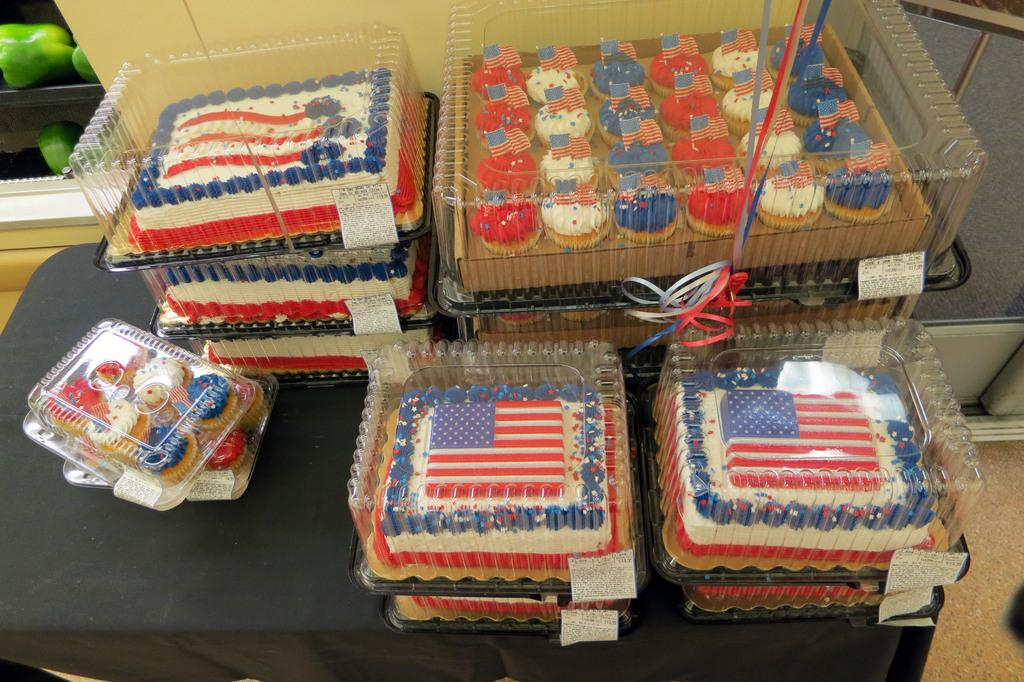What type of food items are present in the image? There are cakes and muffins in the image. How are the cakes and muffins packaged? The cakes and muffins are packed in polythene cartons. Where are the cakes and muffins placed? The cakes and muffins are placed on a table. Can you see any fairies helping to pack the cakes and muffins in the image? There are no fairies present in the image. What sense is being utilized by the fairies to pack the cakes and muffins in the image? There are no fairies present in the image, so it is not possible to determine which sense they might be using. 